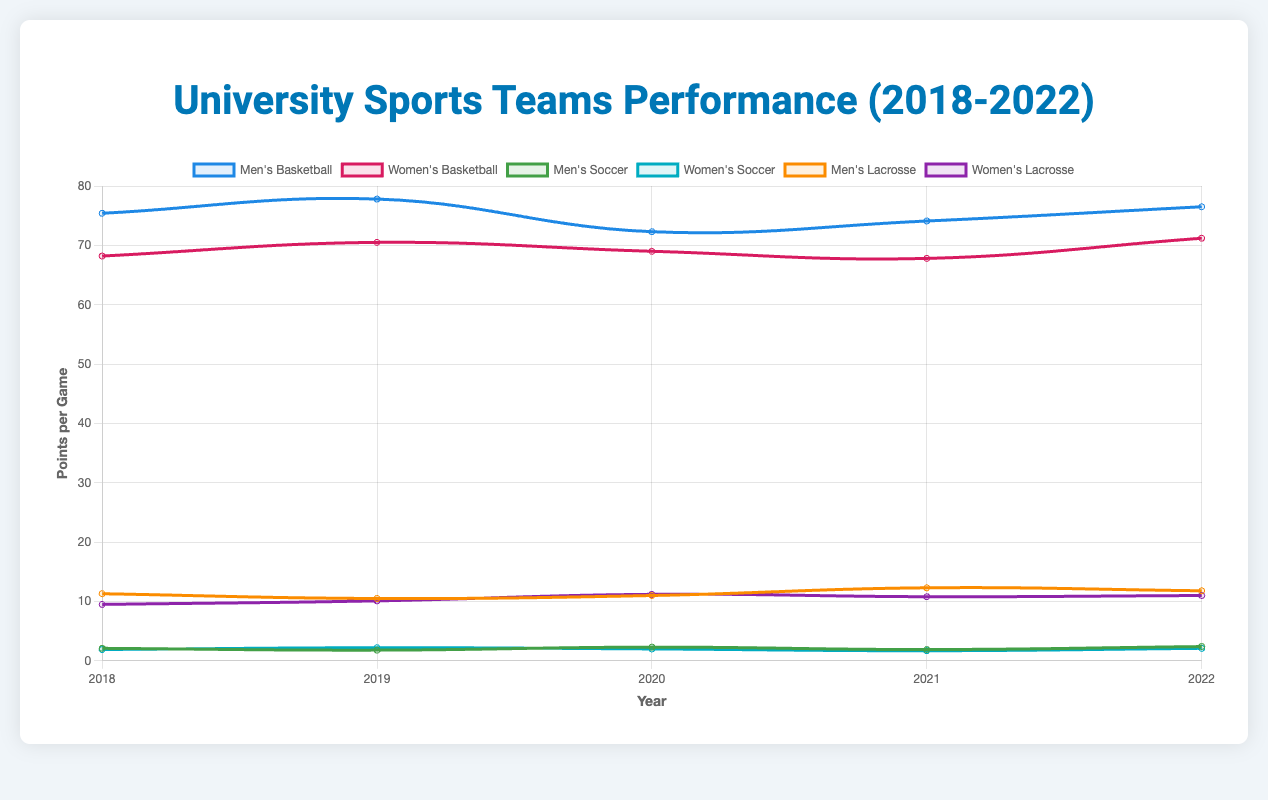Which team scored the most points per game in 2022? By looking at the line plot and identifying the highest point for the year 2022, we can determine that Men's Basketball scored the most points per game at 76.5 points.
Answer: Men's Basketball How did the Women's Lacrosse team's points per game change from 2018 to 2022? To find the change in points per game, subtract the 2018 value (9.5) from the 2022 value (11.0): 11.0 - 9.5 = 1.5. So, the Women's Lacrosse team's points per game increased by 1.5 points.
Answer: Increased by 1.5 points Which year did Men's Soccer see their highest points per game? Observe the line plot for Men's Soccer and note the highest vertical point across the years. The highest value is 2.4 in 2022.
Answer: 2022 Compare the points per game for Men's and Women's Basketball in 2020. Which team had higher points per game, and by how much? Compare the data points for both teams in 2020: Men's Basketball (72.3) and Women's Basketball (69.0). The difference is 72.3 - 69.0 = 3.3. Men's Basketball scored 3.3 points per game more than Women's Basketball.
Answer: Men's Basketball by 3.3 points What is the average points per game for Men's Lacrosse from 2018 to 2022? Sum the points per game for Men's Lacrosse over the years: 11.3 (2018) + 10.5 (2019) + 11.0 (2020) + 12.3 (2021) + 11.8 (2022) = 56.9. Divide this by the number of years (5): 56.9 / 5 = 11.38.
Answer: 11.38 By how much did Women's Basketball points per game increase from 2018 to 2022, and is this greater than the increase in Men's Basketball over the same period? Women's Basketball increased from 68.2 (2018) to 71.2 (2022), resulting in an increase of 71.2 - 68.2 = 3.0 points. Men's Basketball increased from 75.4 (2018) to 76.5 (2022), resulting in an increase of 76.5 - 75.4 = 1.1 points. Hence, the increase in Women's Basketball (3.0 points) is greater than the increase in Men's Basketball (1.1 points).
Answer: 3.0 points, Yes Identify the team that experienced the largest increase in points per game from 2020 to 2021. Compare the difference in points per game between 2020 and 2021 for all teams. The team with the largest increase is Men's Lacrosse: 12.3 (2021) - 11.0 (2020) = 1.3 points.
Answer: Men's Lacrosse Which team had the lowest points per game in any year, and what was that value? Inspect the line plot for the lowest point across all years and teams. Women's Soccer had the lowest points per game at 1.7 in 2021.
Answer: Women's Soccer, 1.7 